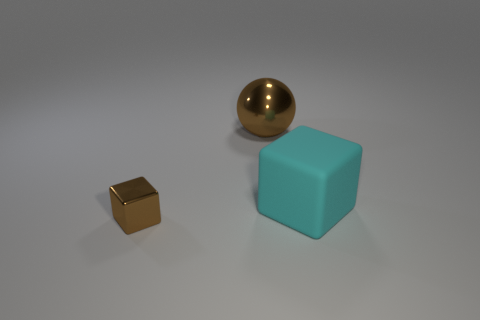Subtract all cyan cubes. How many cubes are left? 1 Add 1 brown spheres. How many objects exist? 4 Subtract all blocks. How many objects are left? 1 Subtract 1 cubes. How many cubes are left? 1 Subtract all blue spheres. Subtract all green cubes. How many spheres are left? 1 Subtract all purple balls. How many brown cubes are left? 1 Subtract all small blocks. Subtract all tiny cyan matte things. How many objects are left? 2 Add 3 large cyan objects. How many large cyan objects are left? 4 Add 2 brown spheres. How many brown spheres exist? 3 Subtract 0 purple cubes. How many objects are left? 3 